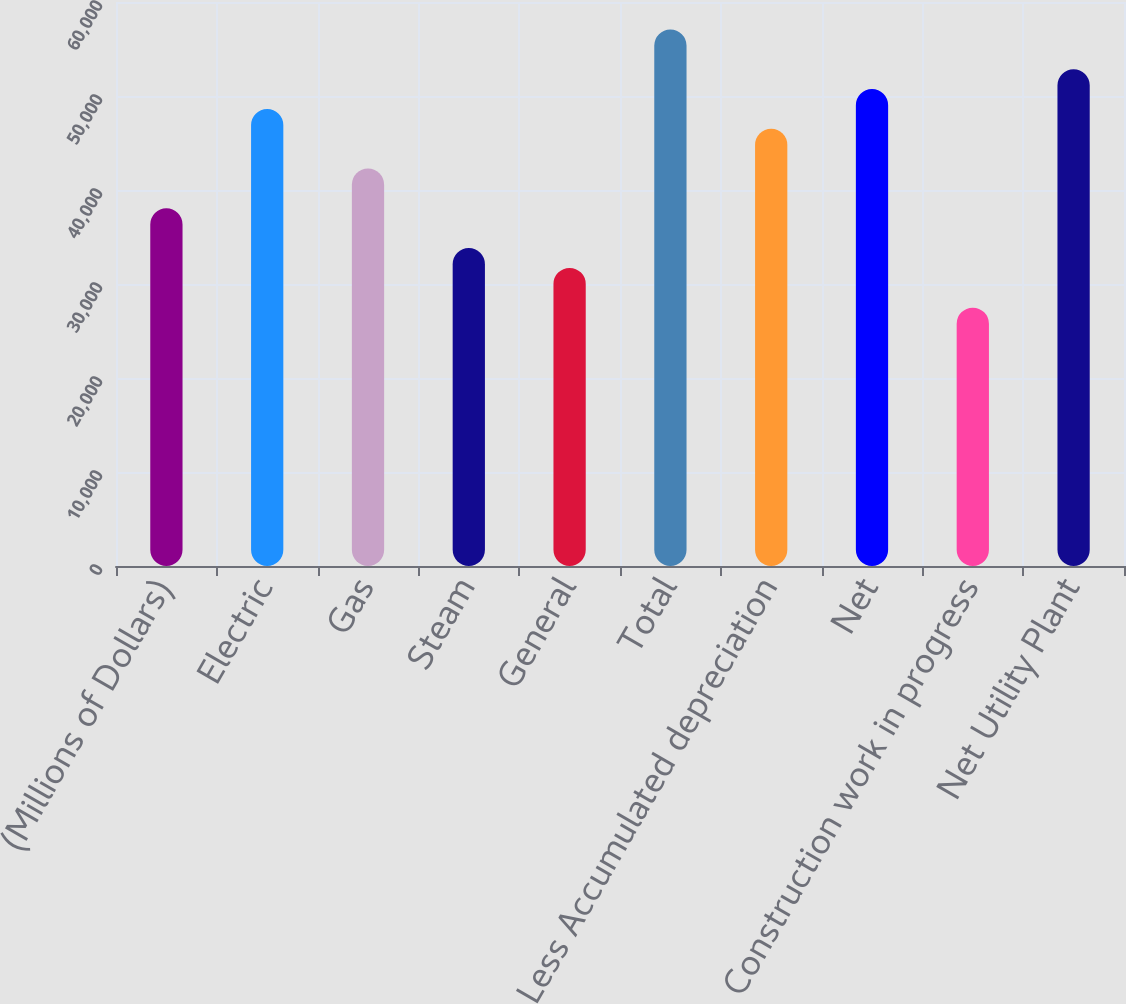Convert chart to OTSL. <chart><loc_0><loc_0><loc_500><loc_500><bar_chart><fcel>(Millions of Dollars)<fcel>Electric<fcel>Gas<fcel>Steam<fcel>General<fcel>Total<fcel>Less Accumulated depreciation<fcel>Net<fcel>Construction work in progress<fcel>Net Utility Plant<nl><fcel>38056<fcel>48626<fcel>42284<fcel>33828<fcel>31714<fcel>57082<fcel>46512<fcel>50740<fcel>27486<fcel>52854<nl></chart> 